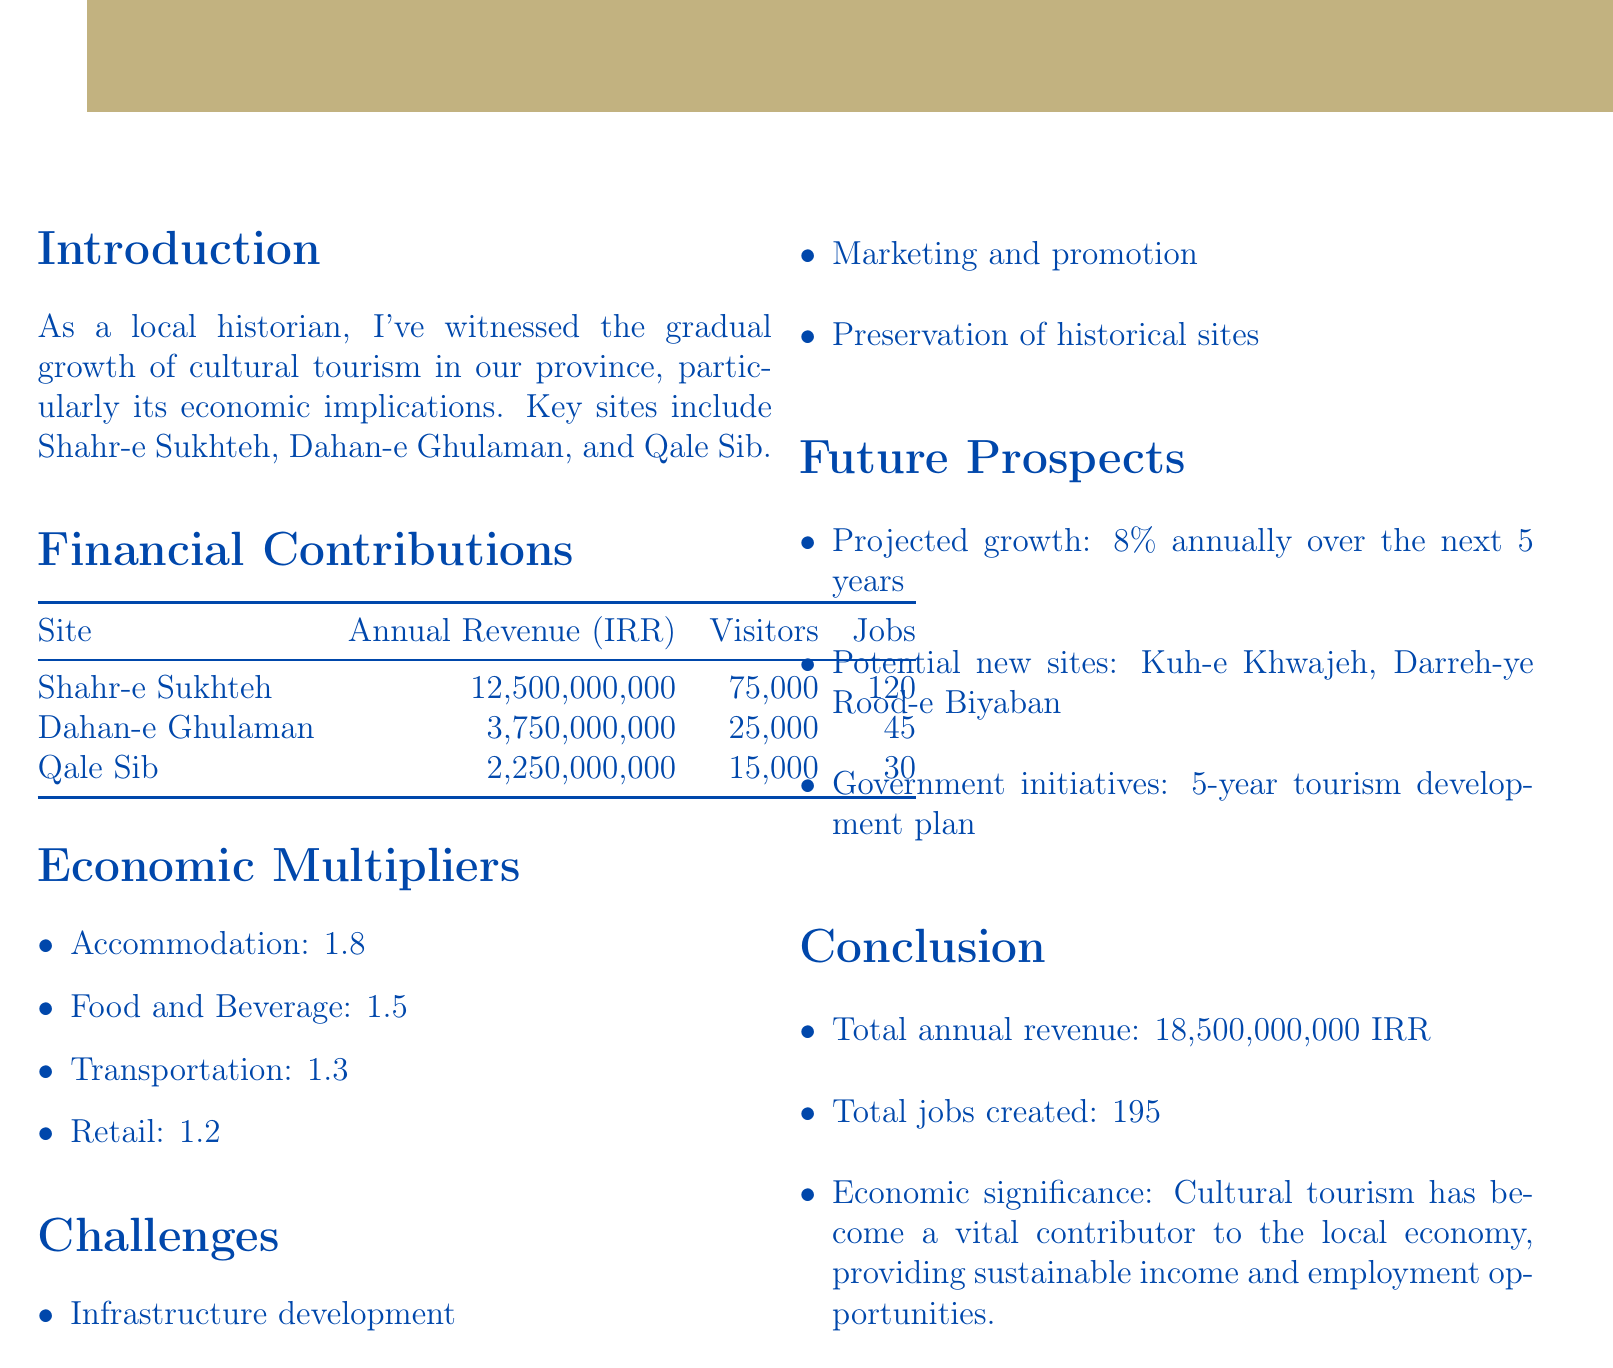What is the annual revenue of Shahr-e Sukhteh? The annual revenue for Shahr-e Sukhteh is specified in the document as 12,500,000,000 Iranian Rial.
Answer: 12,500,000,000 Iranian Rial How many jobs were created by Dahan-e Ghulaman? The document states that Dahan-e Ghulaman created 45 jobs.
Answer: 45 What is the projected growth rate for tourism in the next 5 years? The document indicates a projected growth rate of 8% annually over the next 5 years.
Answer: 8% Which site has the highest visitor count? The highest visitor count among the sites listed is for Shahr-e Sukhteh at 75,000 visitors.
Answer: Shahr-e Sukhteh What are the economic multipliers for food and beverage? The multiplier for food and beverage is cited as 1.5 in the document.
Answer: 1.5 What challenges are mentioned in the report? The challenges listed in the report include infrastructure development, marketing and promotion, and preservation of historical sites.
Answer: Infrastructure development, marketing and promotion, preservation of historical sites What is the total annual revenue from all sites? The total annual revenue, as summarized in the conclusion, amounts to 18,500,000,000 Iranian Rial.
Answer: 18,500,000,000 Iranian Rial What is the name of a potential new site for tourism? The document mentions Kuh-e Khwajeh as a potential new site for tourism.
Answer: Kuh-e Khwajeh 